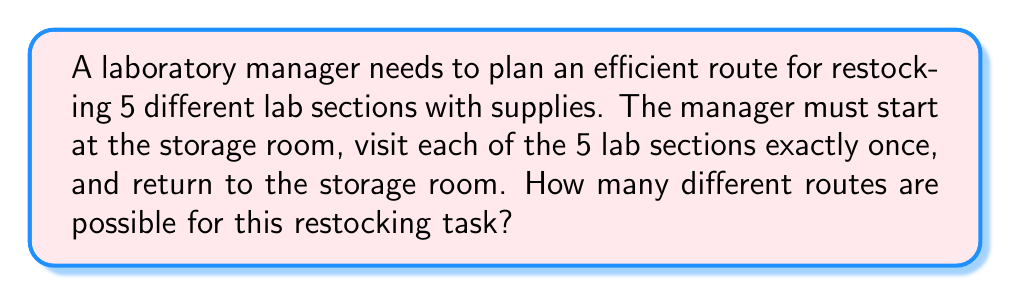What is the answer to this math problem? Let's approach this step-by-step:

1) This problem is essentially asking for the number of permutations of 5 lab sections, with a fixed start and end point (the storage room).

2) For permutations of n distinct objects, we typically use the formula $n!$. However, in this case, we're dealing with a circular permutation because the start and end points are fixed.

3) For circular permutations, we divide the regular permutation formula by n, because rotations of the same order are considered identical in a circular arrangement.

4) In this case, we have 5 lab sections to arrange, so our calculation will be:

   $$\frac{5!}{5} = \frac{5 \cdot 4 \cdot 3 \cdot 2 \cdot 1}{5} = 4 \cdot 3 \cdot 2 \cdot 1 = 24$$

5) Therefore, there are 24 different possible routes for the laboratory manager to efficiently restock all 5 lab sections.
Answer: 24 